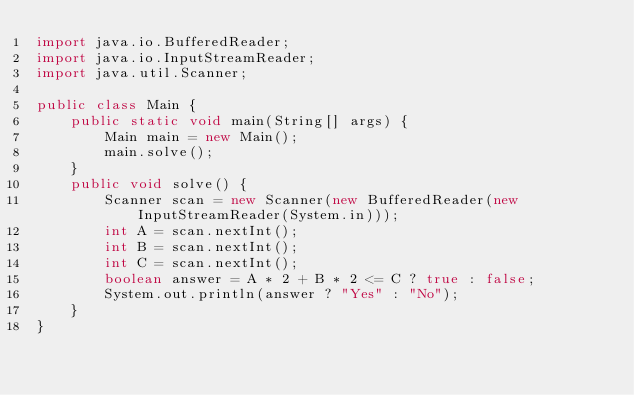Convert code to text. <code><loc_0><loc_0><loc_500><loc_500><_Java_>import java.io.BufferedReader;
import java.io.InputStreamReader;
import java.util.Scanner;

public class Main {
    public static void main(String[] args) {
        Main main = new Main();
        main.solve();
    }
    public void solve() {
        Scanner scan = new Scanner(new BufferedReader(new InputStreamReader(System.in)));
        int A = scan.nextInt();
        int B = scan.nextInt();
        int C = scan.nextInt();
        boolean answer = A * 2 + B * 2 <= C ? true : false;
        System.out.println(answer ? "Yes" : "No");
    }
}
</code> 